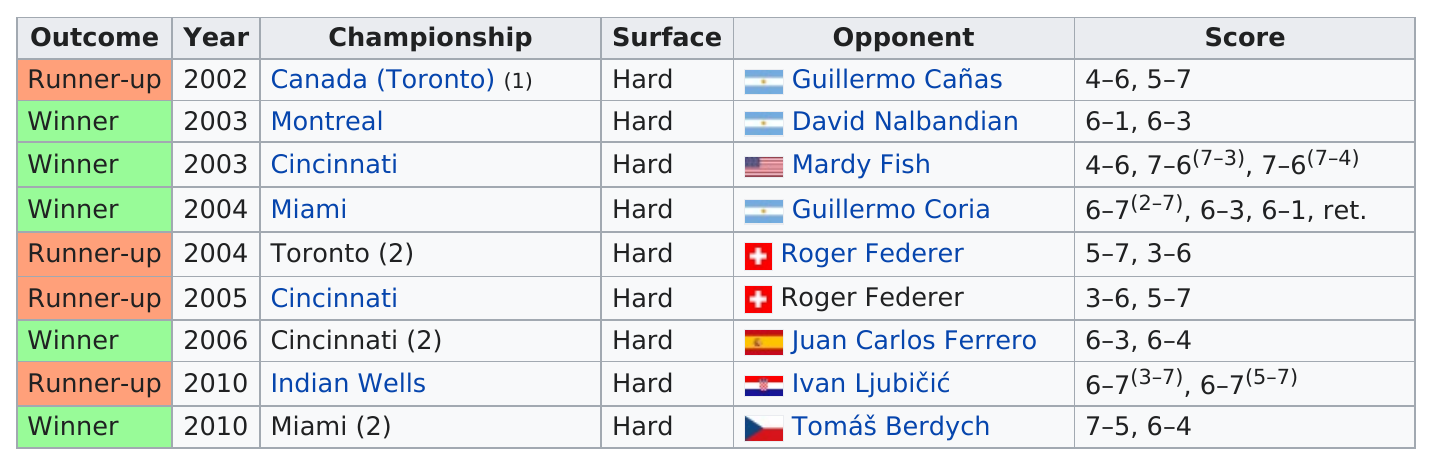Identify some key points in this picture. Roger Federer was a runner-up on two occasions. He has been the runner-up four times. The longest winning streak was three wins in a row. I have determined that the individual in question has achieved a record of three consecutive victories. Roddick's opponents were not from the USA a total of 8 times. 